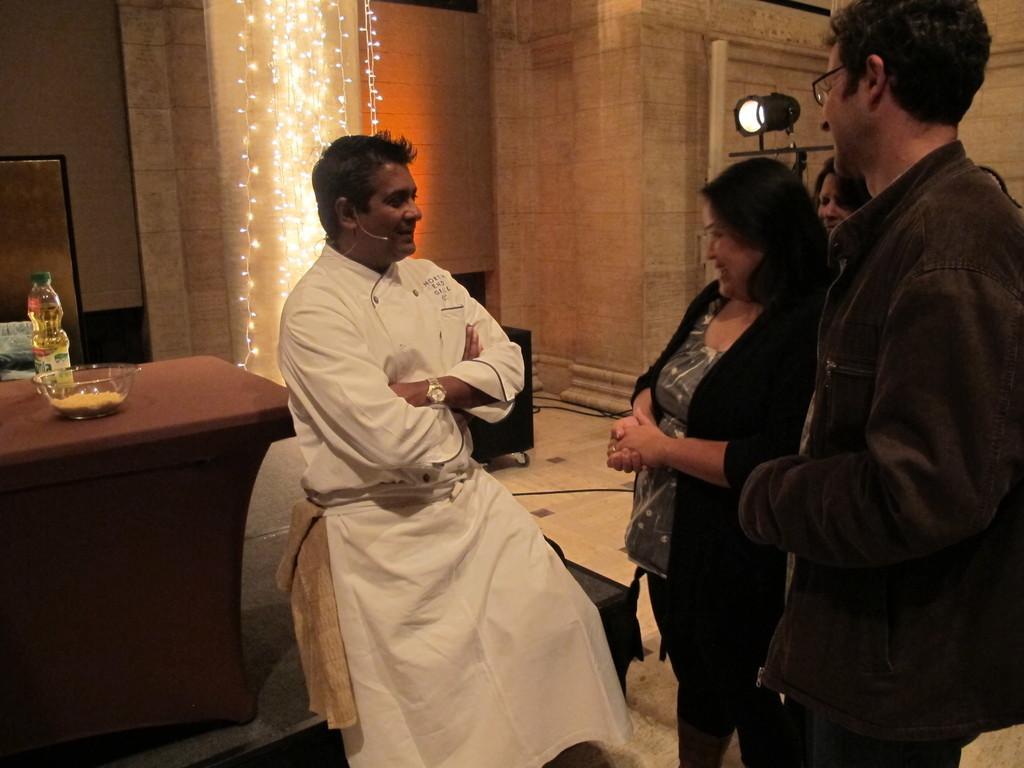In one or two sentences, can you explain what this image depicts? In this picture we can see four people where one man is leaning to the table and talking on mic and this three people are looking at him and on table we can see bowl, bottle and in background we can see wall, lights. 